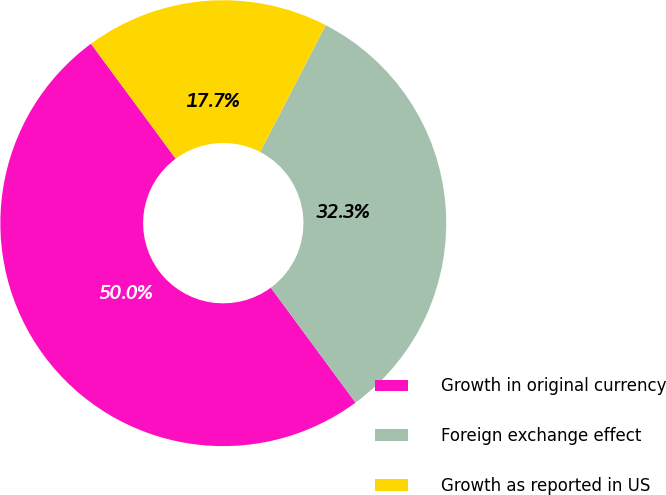Convert chart. <chart><loc_0><loc_0><loc_500><loc_500><pie_chart><fcel>Growth in original currency<fcel>Foreign exchange effect<fcel>Growth as reported in US<nl><fcel>50.0%<fcel>32.29%<fcel>17.71%<nl></chart> 